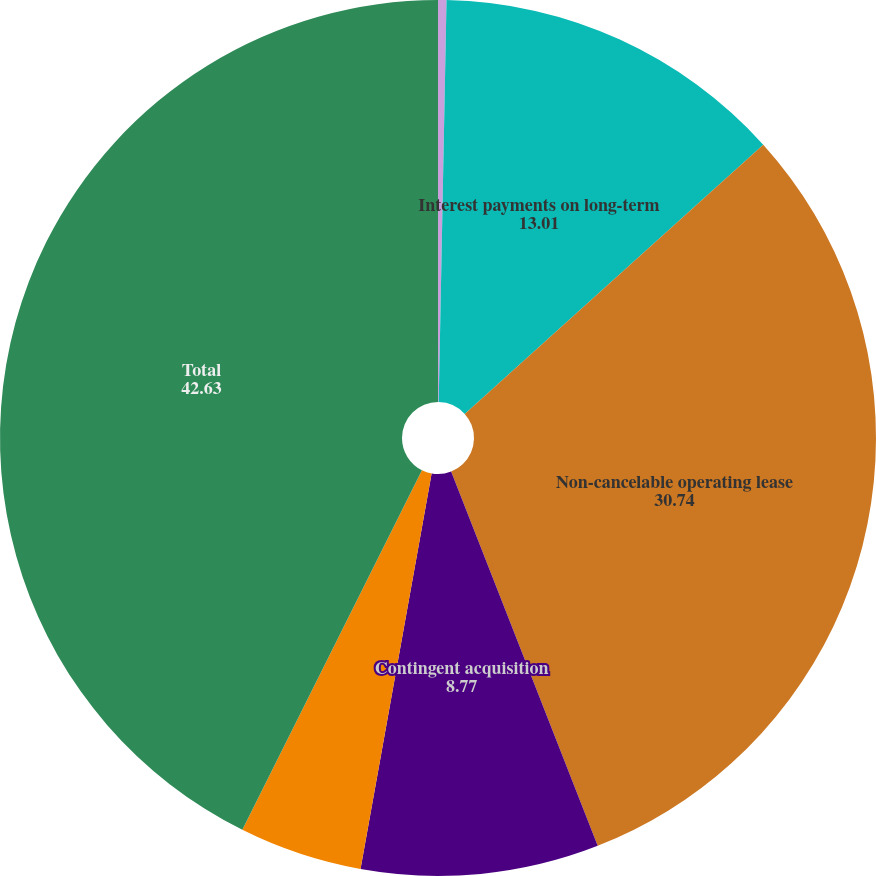<chart> <loc_0><loc_0><loc_500><loc_500><pie_chart><fcel>Long-term debt 1<fcel>Interest payments on long-term<fcel>Non-cancelable operating lease<fcel>Contingent acquisition<fcel>Uncertain tax positions 4<fcel>Total<nl><fcel>0.31%<fcel>13.01%<fcel>30.74%<fcel>8.77%<fcel>4.54%<fcel>42.63%<nl></chart> 